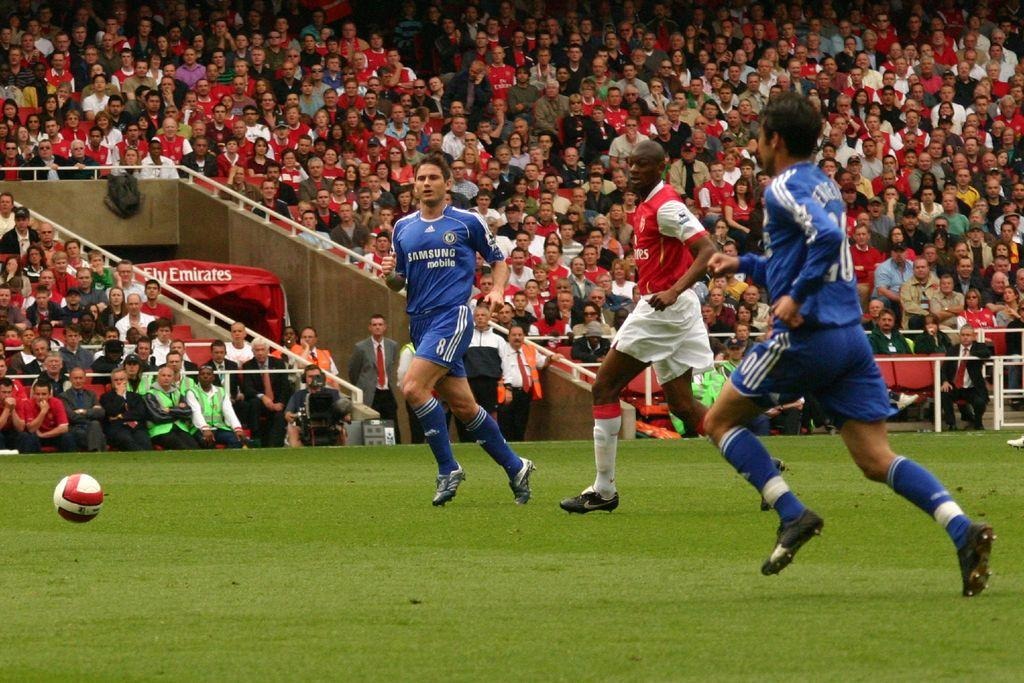How many players are involved in the game in the image? There are three players in the image. What sport are the players engaged in? The players are playing soccer. Where is the soccer game taking place? The soccer game is taking place in a field. Who is watching the game? There are spectators in the image. From where are the spectators watching the game? The spectators are watching the game from stands. Can you hear the vase laughing in the image? There is no vase present in the image, and therefore it cannot be heard laughing. 